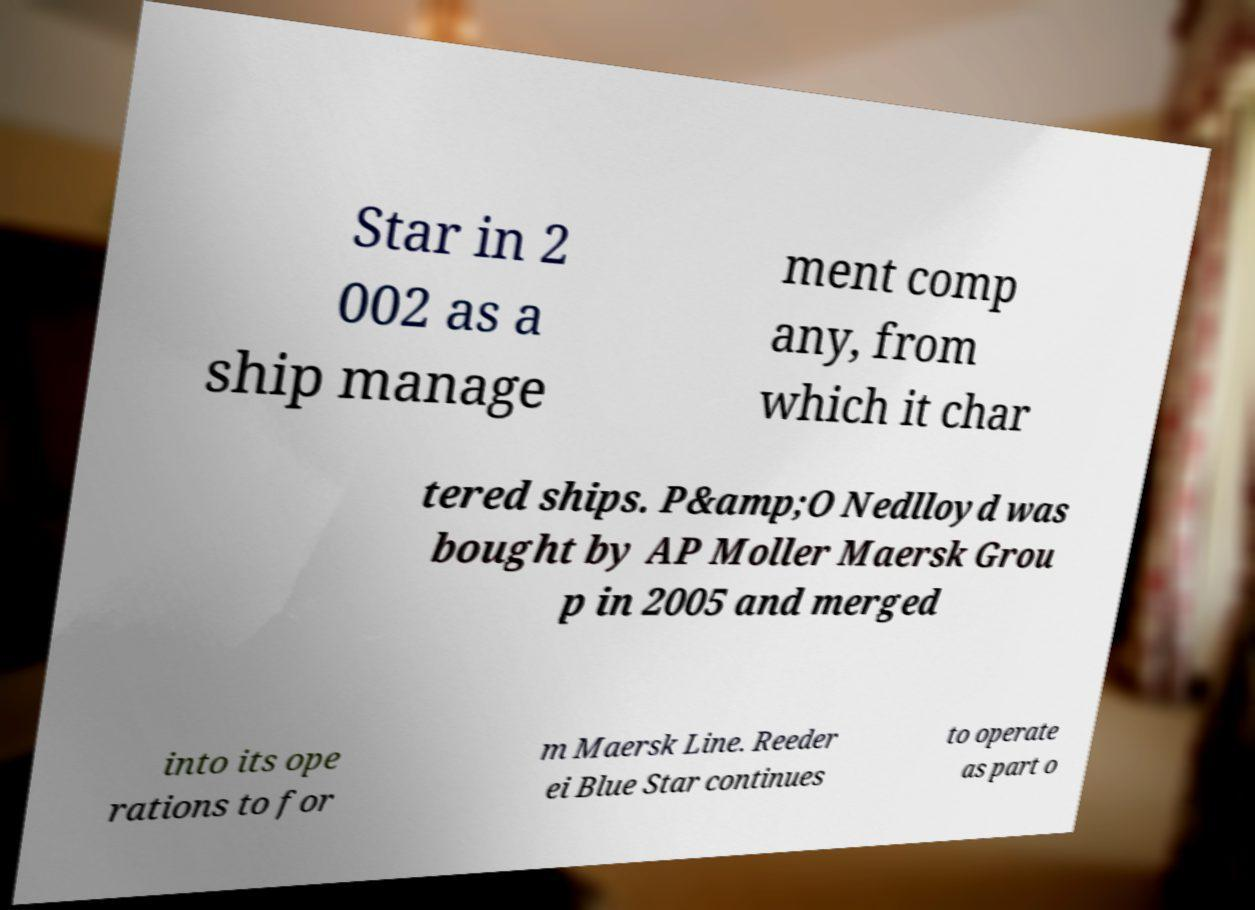Please identify and transcribe the text found in this image. Star in 2 002 as a ship manage ment comp any, from which it char tered ships. P&amp;O Nedlloyd was bought by AP Moller Maersk Grou p in 2005 and merged into its ope rations to for m Maersk Line. Reeder ei Blue Star continues to operate as part o 